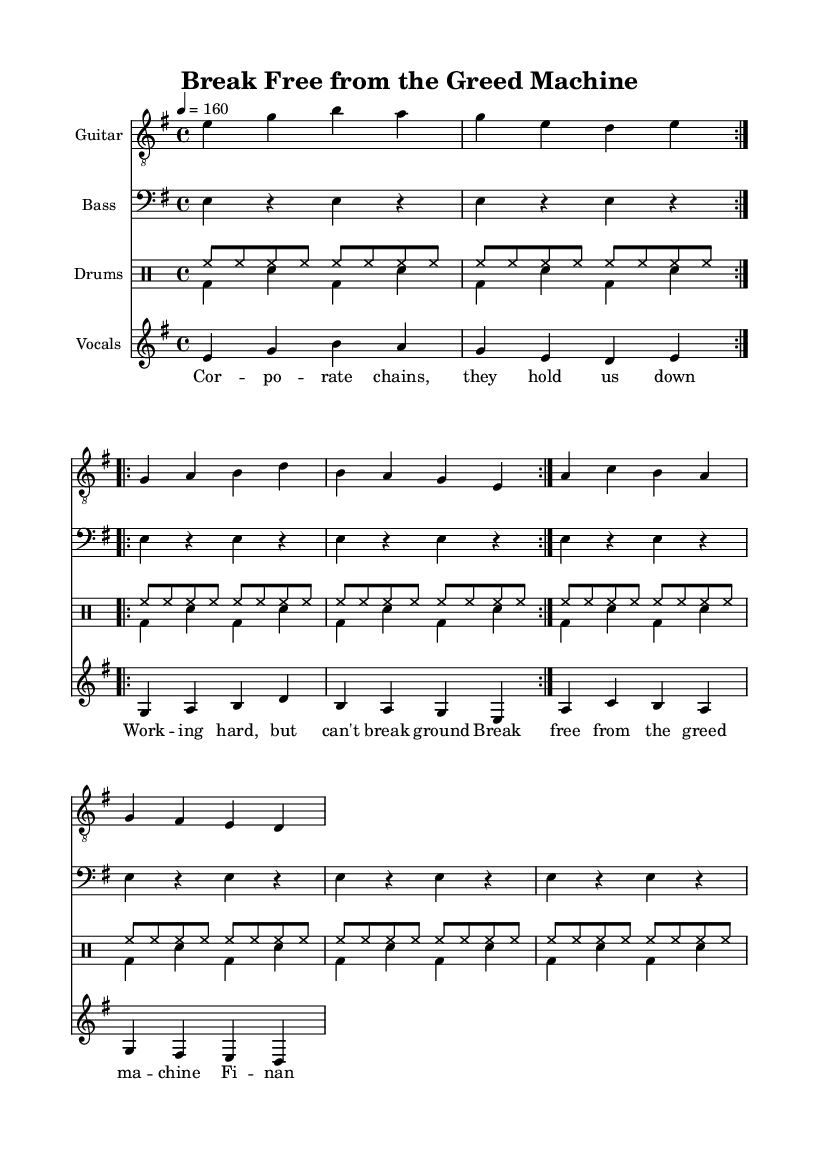What is the key signature of this music? The key signature is E minor, which has one sharp (F#). It is indicated at the beginning of the score.
Answer: E minor What is the time signature of this piece? The time signature is 4/4, which means there are four beats in a measure and the quarter note gets one beat. This is noted at the beginning of the score.
Answer: 4/4 What is the tempo marking for the music? The tempo marking is 160 beats per minute, indicated at the start of the score. This means the piece should be played at a fast pace.
Answer: 160 How many times is the verse repeated? The verse is repeated 2 times, as indicated by the repeat instructions in the code segment.
Answer: 2 What is the main theme of the lyrics? The main theme discusses breaking free from corporate greed and achieving financial independence. This is elaborated through phrases like "Break free from the greed machine."
Answer: Breaking free from corporate greed What is the role of the drums in this piece? The drums provide both pitched and unpitched sounds that contribute to the overall rhythm and energy typical of punk music, emphasizing the beat and enhancing the song's intensity.
Answer: Rhythm and energy How does the bridge contribute to the song's message? The bridge emphasizes confrontation against corporate lies and reassures the listener that freedom should not be compromised. It heightens the emotional intensity of the song's message regarding independence.
Answer: Emphasizes confrontation 